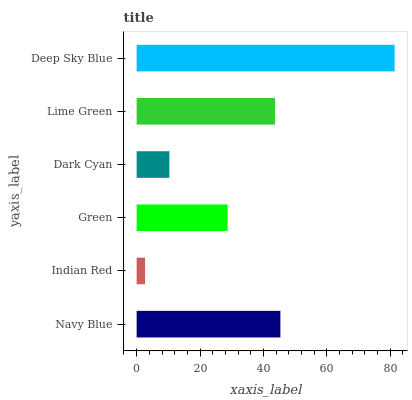Is Indian Red the minimum?
Answer yes or no. Yes. Is Deep Sky Blue the maximum?
Answer yes or no. Yes. Is Green the minimum?
Answer yes or no. No. Is Green the maximum?
Answer yes or no. No. Is Green greater than Indian Red?
Answer yes or no. Yes. Is Indian Red less than Green?
Answer yes or no. Yes. Is Indian Red greater than Green?
Answer yes or no. No. Is Green less than Indian Red?
Answer yes or no. No. Is Lime Green the high median?
Answer yes or no. Yes. Is Green the low median?
Answer yes or no. Yes. Is Dark Cyan the high median?
Answer yes or no. No. Is Navy Blue the low median?
Answer yes or no. No. 